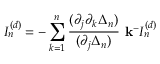Convert formula to latex. <formula><loc_0><loc_0><loc_500><loc_500>I _ { n } ^ { ( d ) } = - \sum _ { k = 1 } ^ { n } \frac { ( \partial _ { j } \partial _ { k } \Delta _ { n } ) } { ( \partial _ { j } \Delta _ { n } ) } { k ^ { - } } I _ { n } ^ { ( d ) }</formula> 